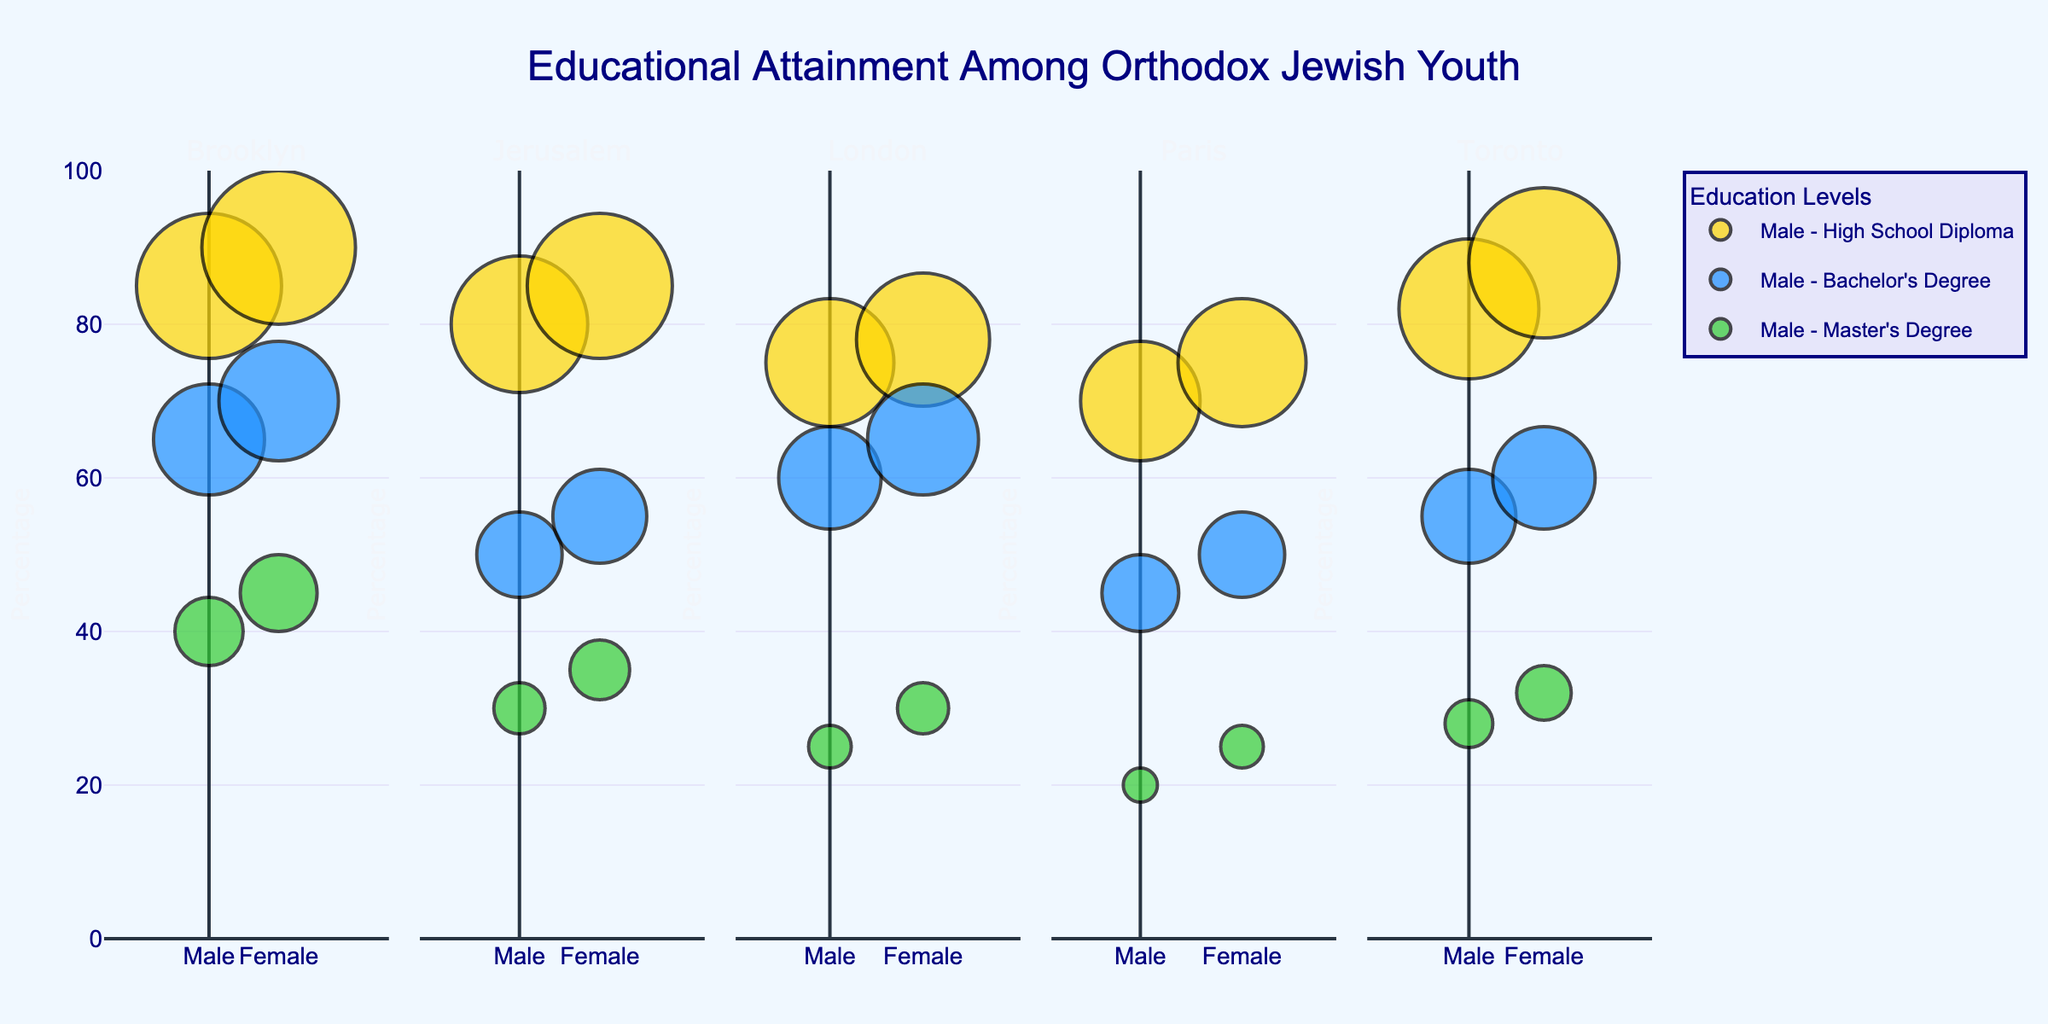What is the title of the figure? The title of the figure is prominently displayed at the top center.
Answer: Educational Attainment Among Orthodox Jewish Youth Which region has the highest percentage of females with a Master's Degree? By looking at the y-axis values for females in each region, you can compare the heights of the green transparent bubbles. The highest green transparent bubble for females indicates the highest percentage.
Answer: Brooklyn What is the difference in percentage of males with a Bachelor's Degree between Brooklyn and Jerusalem? Find the y-values for males with a Bachelor's Degree in Brooklyn and Jerusalem. The value for Brooklyn is 65, and for Jerusalem it is 50. Compute the difference. 65 - 50 = 15
Answer: 15 In which region is the percentage of females with a High School Diploma greater than males with a Bachelor's Degree? For each region, compare the y-value of the female’s yellow transparent bubble (High School Diploma) to the y-value of the male’s blue transparent bubble (Bachelor's Degree).
Answer: Brooklyn, Toronto Compare the educational attainment of males in London with that of females in Paris. Which gender and region show higher educational attainment at the Bachelor's level? Look at the blue bubbles for males in London and females in Paris, then compare their y-values. The y-value for males in London is 60, and for females in Paris it is 50.
Answer: Males in London What is the average percentage of females with a Bachelor's Degree across all regions? Find the y-values for females with a Bachelor's Degree in each region: Brooklyn (70), Jerusalem (55), London (65), Paris (50), and Toronto (60). Calculate the average: (70 + 55 + 65 + 50 + 60)/5 = 60
Answer: 60 Which region shows a smaller gender gap in the percentage of High School Diploma attainment? Calculate the absolute difference between males and females for the yellow transparent bubbles (High School Diploma) in each region: Brooklyn (5), Jerusalem (5), London (3), Paris (5), Toronto (6). The smallest gap is 3 in London.
Answer: London At the Master's Degree level, which gender shows a higher percentage on average across all the regions? Calculate the average percentage of males and females with a Master's Degree across all regions. For males: (40 + 30 + 25 + 20 + 28)/5 = 28.6. For females: (45 + 35 + 30 + 25 + 32)/5 = 33.4.
Answer: Females 